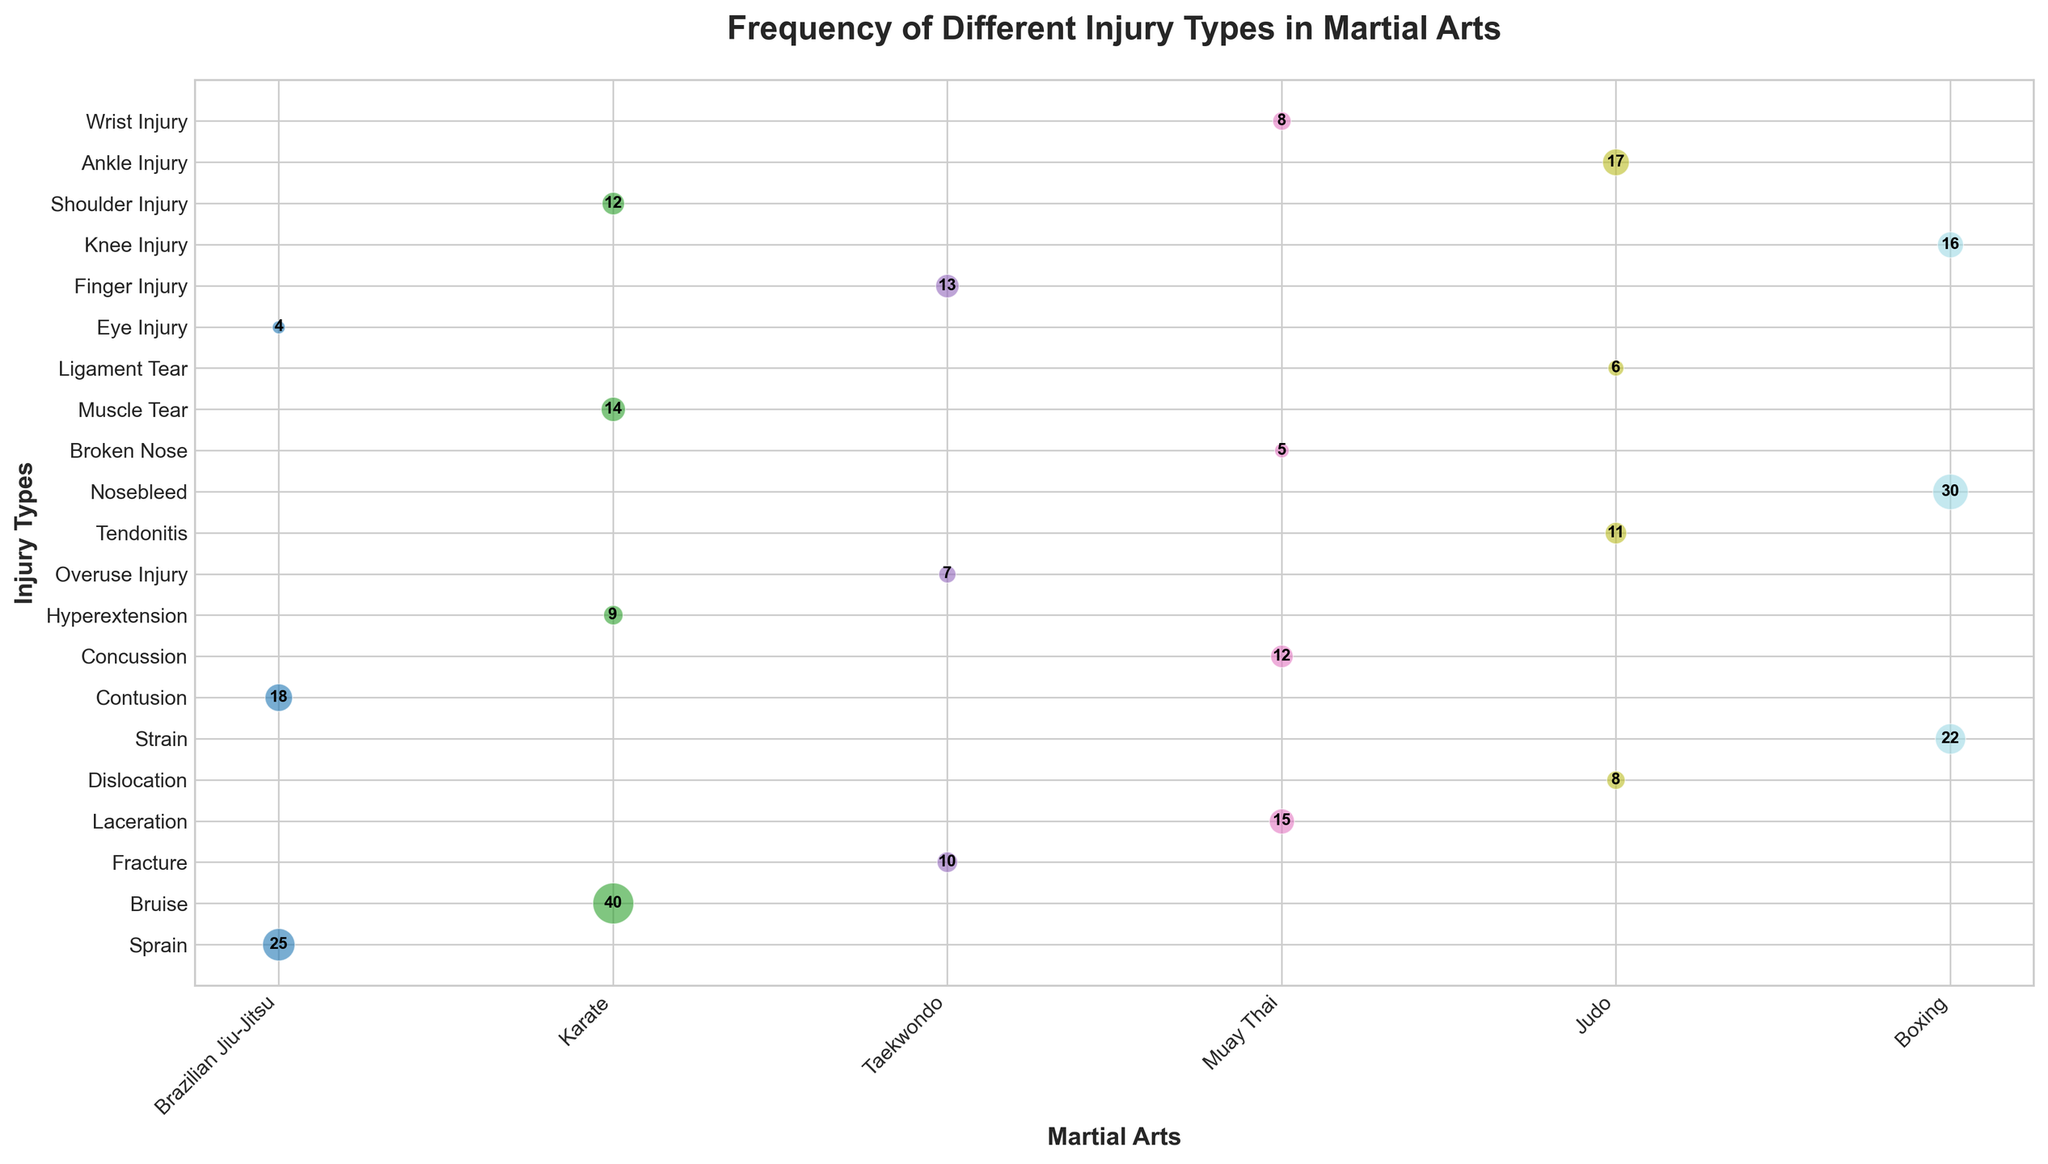Which martial art has the highest frequency of bruises? Look at the size of the bubble labeled "Bruise" and identify the corresponding martial art. The largest bubble for bruises is in Karate.
Answer: Karate Which type of injury is most common in Boxing? Identify the largest bubble within the category of Boxing by comparing bubble sizes. The bubble marked "Nosebleed" is the largest.
Answer: Nosebleed How does the frequency of fractures in Taekwondo compare to knee injuries in Boxing? Compare the bubble sizes and numbers for "Fracture" in Taekwondo and "Knee Injury" in Boxing. The fracture bubble indicates a frequency of 10, while the knee injury bubble indicates 16.
Answer: Knee injuries are more common What is the combined frequency of sprains and eye injuries in Brazilian Jiu-Jitsu? Add the frequencies of sprains and eye injuries found in the Brazilian Jiu-Jitsu category. 25 (sprain) + 4 (eye injury) = 29.
Answer: 29 Which martial art is associated with contusions? Examine the bubble labeled "Contusion" and identify the corresponding martial art. The bubble showing "Contusion" corresponds to Brazilian Jiu-Jitsu.
Answer: Brazilian Jiu-Jitsu Are finger injuries or tendonitis more frequent in Taekwondo and Judo, respectively? Compare "Finger Injury" in Taekwondo and "Tendonitis" in Judo by looking at their bubble sizes and corresponding frequencies. Finger injuries have a frequency of 13 in Taekwondo and tendonitis has 11 in Judo.
Answer: Finger injuries are more frequent How does the frequency of hyperextension injuries in Karate compare to dislocations in Judo? Compare the size of the bubble for hyperextension in Karate to the size of the bubble for dislocations in Judo and their frequencies. Hyperextension has a frequency of 9, while dislocations have a frequency of 8.
Answer: Hyperextension injuries are more frequent What is the total frequency of all reported injuries in Muay Thai? Sum all the frequencies of different injury types listed under Muay Thai. The frequencies are 15 (laceration), 12 (concussion), 5 (broken nose), and 8 (wrist injury). 15 + 12 + 5 + 8 = 40.
Answer: 40 How many more bruises are there in Karate compared to tendonitis in Judo? Subtract the frequency of tendonitis in Judo from the frequency of bruises in Karate. Bruises have a frequency of 40 and tendonitis has 11. 40 - 11 = 29.
Answer: 29 